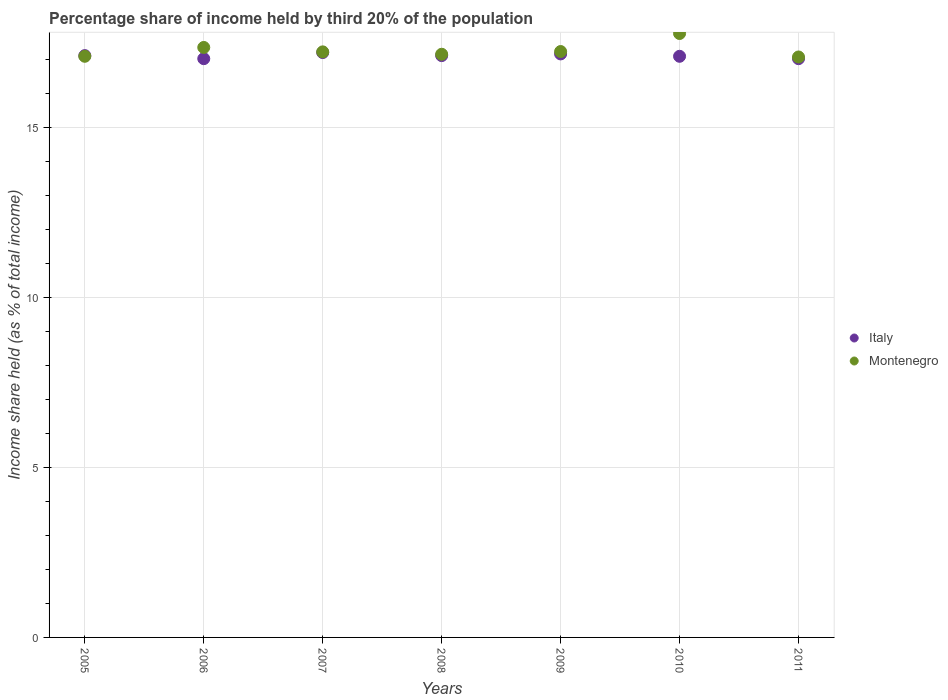How many different coloured dotlines are there?
Your answer should be compact. 2. What is the share of income held by third 20% of the population in Montenegro in 2010?
Your response must be concise. 17.76. Across all years, what is the minimum share of income held by third 20% of the population in Italy?
Offer a very short reply. 17.02. In which year was the share of income held by third 20% of the population in Italy maximum?
Provide a succinct answer. 2007. In which year was the share of income held by third 20% of the population in Montenegro minimum?
Provide a short and direct response. 2011. What is the total share of income held by third 20% of the population in Italy in the graph?
Ensure brevity in your answer.  119.71. What is the difference between the share of income held by third 20% of the population in Montenegro in 2007 and that in 2009?
Provide a short and direct response. -0.01. What is the difference between the share of income held by third 20% of the population in Montenegro in 2006 and the share of income held by third 20% of the population in Italy in 2008?
Your answer should be very brief. 0.24. What is the average share of income held by third 20% of the population in Montenegro per year?
Offer a very short reply. 17.27. In the year 2010, what is the difference between the share of income held by third 20% of the population in Montenegro and share of income held by third 20% of the population in Italy?
Provide a short and direct response. 0.67. In how many years, is the share of income held by third 20% of the population in Montenegro greater than 8 %?
Your answer should be compact. 7. What is the ratio of the share of income held by third 20% of the population in Montenegro in 2005 to that in 2009?
Provide a succinct answer. 0.99. Is the share of income held by third 20% of the population in Montenegro in 2006 less than that in 2009?
Provide a short and direct response. No. What is the difference between the highest and the second highest share of income held by third 20% of the population in Italy?
Offer a terse response. 0.04. What is the difference between the highest and the lowest share of income held by third 20% of the population in Italy?
Your answer should be very brief. 0.18. In how many years, is the share of income held by third 20% of the population in Montenegro greater than the average share of income held by third 20% of the population in Montenegro taken over all years?
Ensure brevity in your answer.  2. Does the share of income held by third 20% of the population in Montenegro monotonically increase over the years?
Your response must be concise. No. Is the share of income held by third 20% of the population in Montenegro strictly greater than the share of income held by third 20% of the population in Italy over the years?
Your answer should be very brief. No. How many years are there in the graph?
Keep it short and to the point. 7. What is the difference between two consecutive major ticks on the Y-axis?
Give a very brief answer. 5. Does the graph contain any zero values?
Keep it short and to the point. No. Where does the legend appear in the graph?
Provide a succinct answer. Center right. How are the legend labels stacked?
Give a very brief answer. Vertical. What is the title of the graph?
Your answer should be very brief. Percentage share of income held by third 20% of the population. What is the label or title of the Y-axis?
Keep it short and to the point. Income share held (as % of total income). What is the Income share held (as % of total income) in Italy in 2005?
Offer a terse response. 17.11. What is the Income share held (as % of total income) in Montenegro in 2005?
Offer a very short reply. 17.09. What is the Income share held (as % of total income) of Italy in 2006?
Your response must be concise. 17.02. What is the Income share held (as % of total income) in Montenegro in 2006?
Offer a very short reply. 17.35. What is the Income share held (as % of total income) in Montenegro in 2007?
Keep it short and to the point. 17.22. What is the Income share held (as % of total income) in Italy in 2008?
Your answer should be very brief. 17.11. What is the Income share held (as % of total income) of Montenegro in 2008?
Give a very brief answer. 17.15. What is the Income share held (as % of total income) of Italy in 2009?
Your answer should be compact. 17.16. What is the Income share held (as % of total income) in Montenegro in 2009?
Ensure brevity in your answer.  17.23. What is the Income share held (as % of total income) in Italy in 2010?
Make the answer very short. 17.09. What is the Income share held (as % of total income) of Montenegro in 2010?
Your answer should be very brief. 17.76. What is the Income share held (as % of total income) in Italy in 2011?
Offer a very short reply. 17.02. What is the Income share held (as % of total income) of Montenegro in 2011?
Your answer should be very brief. 17.07. Across all years, what is the maximum Income share held (as % of total income) of Montenegro?
Your answer should be very brief. 17.76. Across all years, what is the minimum Income share held (as % of total income) in Italy?
Offer a very short reply. 17.02. Across all years, what is the minimum Income share held (as % of total income) in Montenegro?
Offer a terse response. 17.07. What is the total Income share held (as % of total income) of Italy in the graph?
Your answer should be compact. 119.71. What is the total Income share held (as % of total income) of Montenegro in the graph?
Ensure brevity in your answer.  120.87. What is the difference between the Income share held (as % of total income) in Italy in 2005 and that in 2006?
Offer a terse response. 0.09. What is the difference between the Income share held (as % of total income) of Montenegro in 2005 and that in 2006?
Make the answer very short. -0.26. What is the difference between the Income share held (as % of total income) in Italy in 2005 and that in 2007?
Your answer should be compact. -0.09. What is the difference between the Income share held (as % of total income) in Montenegro in 2005 and that in 2007?
Provide a short and direct response. -0.13. What is the difference between the Income share held (as % of total income) in Montenegro in 2005 and that in 2008?
Provide a short and direct response. -0.06. What is the difference between the Income share held (as % of total income) in Italy in 2005 and that in 2009?
Your answer should be compact. -0.05. What is the difference between the Income share held (as % of total income) of Montenegro in 2005 and that in 2009?
Ensure brevity in your answer.  -0.14. What is the difference between the Income share held (as % of total income) in Montenegro in 2005 and that in 2010?
Provide a succinct answer. -0.67. What is the difference between the Income share held (as % of total income) of Italy in 2005 and that in 2011?
Your answer should be very brief. 0.09. What is the difference between the Income share held (as % of total income) of Italy in 2006 and that in 2007?
Ensure brevity in your answer.  -0.18. What is the difference between the Income share held (as % of total income) of Montenegro in 2006 and that in 2007?
Offer a terse response. 0.13. What is the difference between the Income share held (as % of total income) of Italy in 2006 and that in 2008?
Provide a short and direct response. -0.09. What is the difference between the Income share held (as % of total income) of Italy in 2006 and that in 2009?
Offer a very short reply. -0.14. What is the difference between the Income share held (as % of total income) in Montenegro in 2006 and that in 2009?
Offer a terse response. 0.12. What is the difference between the Income share held (as % of total income) of Italy in 2006 and that in 2010?
Your response must be concise. -0.07. What is the difference between the Income share held (as % of total income) in Montenegro in 2006 and that in 2010?
Your response must be concise. -0.41. What is the difference between the Income share held (as % of total income) in Montenegro in 2006 and that in 2011?
Provide a short and direct response. 0.28. What is the difference between the Income share held (as % of total income) in Italy in 2007 and that in 2008?
Provide a succinct answer. 0.09. What is the difference between the Income share held (as % of total income) in Montenegro in 2007 and that in 2008?
Your response must be concise. 0.07. What is the difference between the Income share held (as % of total income) of Montenegro in 2007 and that in 2009?
Ensure brevity in your answer.  -0.01. What is the difference between the Income share held (as % of total income) of Italy in 2007 and that in 2010?
Offer a very short reply. 0.11. What is the difference between the Income share held (as % of total income) of Montenegro in 2007 and that in 2010?
Your response must be concise. -0.54. What is the difference between the Income share held (as % of total income) in Italy in 2007 and that in 2011?
Your answer should be very brief. 0.18. What is the difference between the Income share held (as % of total income) in Montenegro in 2007 and that in 2011?
Offer a very short reply. 0.15. What is the difference between the Income share held (as % of total income) in Italy in 2008 and that in 2009?
Provide a succinct answer. -0.05. What is the difference between the Income share held (as % of total income) of Montenegro in 2008 and that in 2009?
Make the answer very short. -0.08. What is the difference between the Income share held (as % of total income) of Montenegro in 2008 and that in 2010?
Provide a short and direct response. -0.61. What is the difference between the Income share held (as % of total income) of Italy in 2008 and that in 2011?
Your response must be concise. 0.09. What is the difference between the Income share held (as % of total income) of Montenegro in 2008 and that in 2011?
Make the answer very short. 0.08. What is the difference between the Income share held (as % of total income) in Italy in 2009 and that in 2010?
Ensure brevity in your answer.  0.07. What is the difference between the Income share held (as % of total income) of Montenegro in 2009 and that in 2010?
Your response must be concise. -0.53. What is the difference between the Income share held (as % of total income) in Italy in 2009 and that in 2011?
Your response must be concise. 0.14. What is the difference between the Income share held (as % of total income) of Montenegro in 2009 and that in 2011?
Provide a short and direct response. 0.16. What is the difference between the Income share held (as % of total income) of Italy in 2010 and that in 2011?
Make the answer very short. 0.07. What is the difference between the Income share held (as % of total income) in Montenegro in 2010 and that in 2011?
Ensure brevity in your answer.  0.69. What is the difference between the Income share held (as % of total income) of Italy in 2005 and the Income share held (as % of total income) of Montenegro in 2006?
Your answer should be very brief. -0.24. What is the difference between the Income share held (as % of total income) of Italy in 2005 and the Income share held (as % of total income) of Montenegro in 2007?
Provide a succinct answer. -0.11. What is the difference between the Income share held (as % of total income) in Italy in 2005 and the Income share held (as % of total income) in Montenegro in 2008?
Make the answer very short. -0.04. What is the difference between the Income share held (as % of total income) of Italy in 2005 and the Income share held (as % of total income) of Montenegro in 2009?
Provide a succinct answer. -0.12. What is the difference between the Income share held (as % of total income) in Italy in 2005 and the Income share held (as % of total income) in Montenegro in 2010?
Give a very brief answer. -0.65. What is the difference between the Income share held (as % of total income) in Italy in 2006 and the Income share held (as % of total income) in Montenegro in 2008?
Give a very brief answer. -0.13. What is the difference between the Income share held (as % of total income) of Italy in 2006 and the Income share held (as % of total income) of Montenegro in 2009?
Your answer should be very brief. -0.21. What is the difference between the Income share held (as % of total income) in Italy in 2006 and the Income share held (as % of total income) in Montenegro in 2010?
Make the answer very short. -0.74. What is the difference between the Income share held (as % of total income) in Italy in 2006 and the Income share held (as % of total income) in Montenegro in 2011?
Give a very brief answer. -0.05. What is the difference between the Income share held (as % of total income) of Italy in 2007 and the Income share held (as % of total income) of Montenegro in 2009?
Give a very brief answer. -0.03. What is the difference between the Income share held (as % of total income) of Italy in 2007 and the Income share held (as % of total income) of Montenegro in 2010?
Provide a succinct answer. -0.56. What is the difference between the Income share held (as % of total income) of Italy in 2007 and the Income share held (as % of total income) of Montenegro in 2011?
Your response must be concise. 0.13. What is the difference between the Income share held (as % of total income) of Italy in 2008 and the Income share held (as % of total income) of Montenegro in 2009?
Make the answer very short. -0.12. What is the difference between the Income share held (as % of total income) of Italy in 2008 and the Income share held (as % of total income) of Montenegro in 2010?
Your answer should be very brief. -0.65. What is the difference between the Income share held (as % of total income) of Italy in 2009 and the Income share held (as % of total income) of Montenegro in 2011?
Provide a short and direct response. 0.09. What is the difference between the Income share held (as % of total income) in Italy in 2010 and the Income share held (as % of total income) in Montenegro in 2011?
Your answer should be very brief. 0.02. What is the average Income share held (as % of total income) in Italy per year?
Your answer should be compact. 17.1. What is the average Income share held (as % of total income) of Montenegro per year?
Make the answer very short. 17.27. In the year 2005, what is the difference between the Income share held (as % of total income) of Italy and Income share held (as % of total income) of Montenegro?
Your response must be concise. 0.02. In the year 2006, what is the difference between the Income share held (as % of total income) of Italy and Income share held (as % of total income) of Montenegro?
Your answer should be very brief. -0.33. In the year 2007, what is the difference between the Income share held (as % of total income) in Italy and Income share held (as % of total income) in Montenegro?
Your answer should be very brief. -0.02. In the year 2008, what is the difference between the Income share held (as % of total income) of Italy and Income share held (as % of total income) of Montenegro?
Ensure brevity in your answer.  -0.04. In the year 2009, what is the difference between the Income share held (as % of total income) of Italy and Income share held (as % of total income) of Montenegro?
Ensure brevity in your answer.  -0.07. In the year 2010, what is the difference between the Income share held (as % of total income) of Italy and Income share held (as % of total income) of Montenegro?
Provide a short and direct response. -0.67. In the year 2011, what is the difference between the Income share held (as % of total income) of Italy and Income share held (as % of total income) of Montenegro?
Offer a terse response. -0.05. What is the ratio of the Income share held (as % of total income) in Italy in 2005 to that in 2008?
Your response must be concise. 1. What is the ratio of the Income share held (as % of total income) of Montenegro in 2005 to that in 2009?
Offer a terse response. 0.99. What is the ratio of the Income share held (as % of total income) in Italy in 2005 to that in 2010?
Provide a succinct answer. 1. What is the ratio of the Income share held (as % of total income) in Montenegro in 2005 to that in 2010?
Offer a very short reply. 0.96. What is the ratio of the Income share held (as % of total income) of Italy in 2006 to that in 2007?
Give a very brief answer. 0.99. What is the ratio of the Income share held (as % of total income) in Montenegro in 2006 to that in 2007?
Your answer should be very brief. 1.01. What is the ratio of the Income share held (as % of total income) in Italy in 2006 to that in 2008?
Provide a short and direct response. 0.99. What is the ratio of the Income share held (as % of total income) of Montenegro in 2006 to that in 2008?
Keep it short and to the point. 1.01. What is the ratio of the Income share held (as % of total income) of Italy in 2006 to that in 2009?
Ensure brevity in your answer.  0.99. What is the ratio of the Income share held (as % of total income) of Italy in 2006 to that in 2010?
Keep it short and to the point. 1. What is the ratio of the Income share held (as % of total income) in Montenegro in 2006 to that in 2010?
Your response must be concise. 0.98. What is the ratio of the Income share held (as % of total income) of Montenegro in 2006 to that in 2011?
Offer a terse response. 1.02. What is the ratio of the Income share held (as % of total income) of Italy in 2007 to that in 2009?
Keep it short and to the point. 1. What is the ratio of the Income share held (as % of total income) in Italy in 2007 to that in 2010?
Offer a very short reply. 1.01. What is the ratio of the Income share held (as % of total income) of Montenegro in 2007 to that in 2010?
Your answer should be compact. 0.97. What is the ratio of the Income share held (as % of total income) in Italy in 2007 to that in 2011?
Your response must be concise. 1.01. What is the ratio of the Income share held (as % of total income) of Montenegro in 2007 to that in 2011?
Your answer should be very brief. 1.01. What is the ratio of the Income share held (as % of total income) in Montenegro in 2008 to that in 2009?
Offer a terse response. 1. What is the ratio of the Income share held (as % of total income) of Italy in 2008 to that in 2010?
Offer a very short reply. 1. What is the ratio of the Income share held (as % of total income) in Montenegro in 2008 to that in 2010?
Make the answer very short. 0.97. What is the ratio of the Income share held (as % of total income) in Italy in 2008 to that in 2011?
Offer a terse response. 1.01. What is the ratio of the Income share held (as % of total income) of Italy in 2009 to that in 2010?
Your answer should be very brief. 1. What is the ratio of the Income share held (as % of total income) of Montenegro in 2009 to that in 2010?
Your response must be concise. 0.97. What is the ratio of the Income share held (as % of total income) in Italy in 2009 to that in 2011?
Your response must be concise. 1.01. What is the ratio of the Income share held (as % of total income) of Montenegro in 2009 to that in 2011?
Make the answer very short. 1.01. What is the ratio of the Income share held (as % of total income) of Montenegro in 2010 to that in 2011?
Provide a succinct answer. 1.04. What is the difference between the highest and the second highest Income share held (as % of total income) in Montenegro?
Give a very brief answer. 0.41. What is the difference between the highest and the lowest Income share held (as % of total income) of Italy?
Provide a short and direct response. 0.18. What is the difference between the highest and the lowest Income share held (as % of total income) in Montenegro?
Offer a terse response. 0.69. 